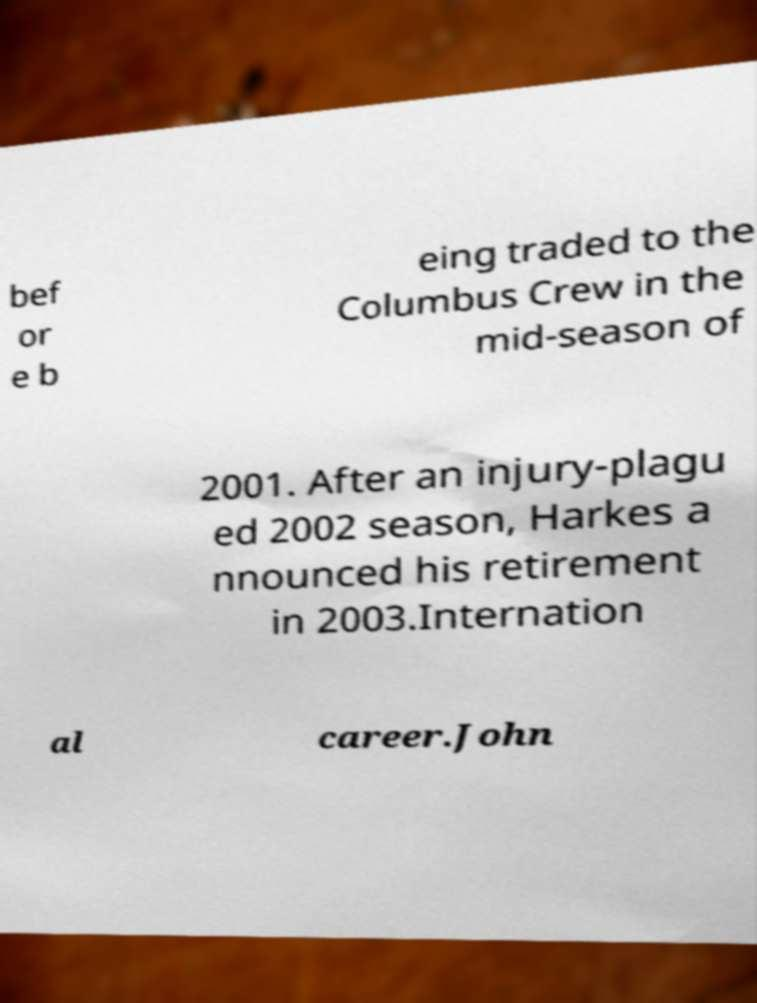Please identify and transcribe the text found in this image. bef or e b eing traded to the Columbus Crew in the mid-season of 2001. After an injury-plagu ed 2002 season, Harkes a nnounced his retirement in 2003.Internation al career.John 